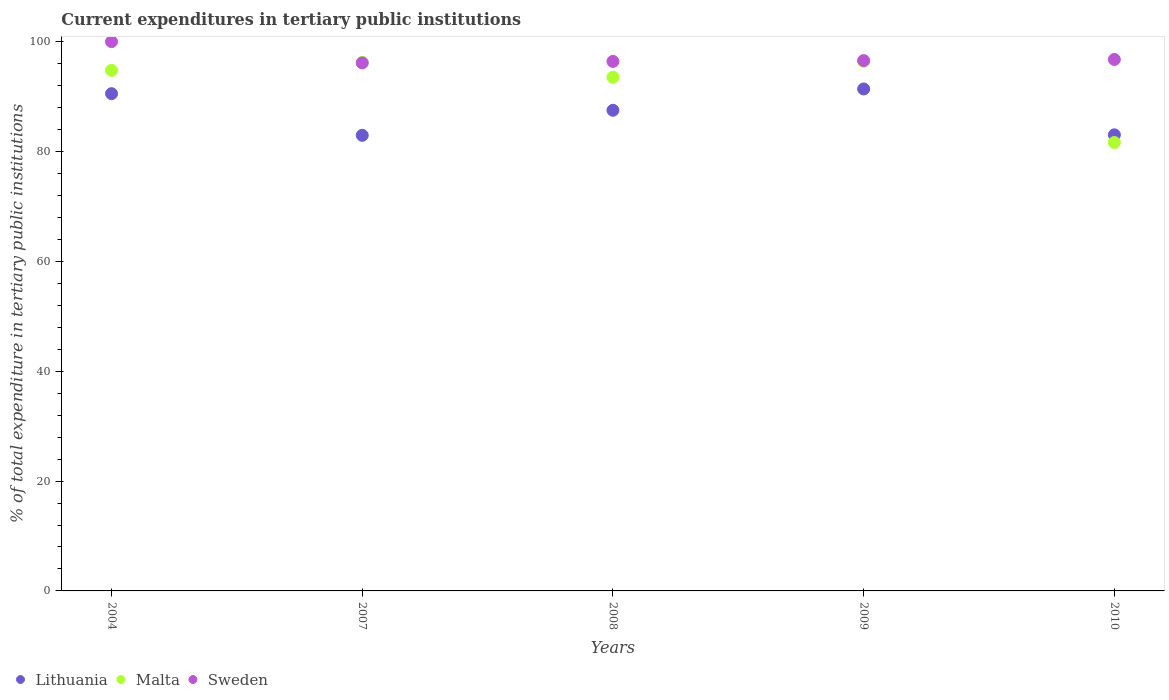How many different coloured dotlines are there?
Your answer should be very brief. 3. What is the current expenditures in tertiary public institutions in Sweden in 2009?
Offer a terse response. 96.54. Across all years, what is the maximum current expenditures in tertiary public institutions in Lithuania?
Offer a terse response. 91.38. Across all years, what is the minimum current expenditures in tertiary public institutions in Malta?
Your answer should be compact. 81.63. What is the total current expenditures in tertiary public institutions in Malta in the graph?
Your answer should be compact. 462.58. What is the difference between the current expenditures in tertiary public institutions in Lithuania in 2007 and that in 2008?
Keep it short and to the point. -4.56. What is the difference between the current expenditures in tertiary public institutions in Sweden in 2004 and the current expenditures in tertiary public institutions in Lithuania in 2008?
Offer a very short reply. 12.5. What is the average current expenditures in tertiary public institutions in Malta per year?
Keep it short and to the point. 92.52. In the year 2004, what is the difference between the current expenditures in tertiary public institutions in Lithuania and current expenditures in tertiary public institutions in Sweden?
Your answer should be compact. -9.48. What is the ratio of the current expenditures in tertiary public institutions in Malta in 2004 to that in 2009?
Keep it short and to the point. 0.98. Is the current expenditures in tertiary public institutions in Lithuania in 2008 less than that in 2009?
Make the answer very short. Yes. What is the difference between the highest and the second highest current expenditures in tertiary public institutions in Malta?
Provide a succinct answer. 0.21. What is the difference between the highest and the lowest current expenditures in tertiary public institutions in Sweden?
Your answer should be very brief. 3.88. In how many years, is the current expenditures in tertiary public institutions in Sweden greater than the average current expenditures in tertiary public institutions in Sweden taken over all years?
Provide a short and direct response. 1. Is the sum of the current expenditures in tertiary public institutions in Malta in 2009 and 2010 greater than the maximum current expenditures in tertiary public institutions in Sweden across all years?
Offer a very short reply. Yes. Is it the case that in every year, the sum of the current expenditures in tertiary public institutions in Lithuania and current expenditures in tertiary public institutions in Sweden  is greater than the current expenditures in tertiary public institutions in Malta?
Provide a short and direct response. Yes. Are the values on the major ticks of Y-axis written in scientific E-notation?
Your answer should be compact. No. Does the graph contain grids?
Give a very brief answer. No. What is the title of the graph?
Your response must be concise. Current expenditures in tertiary public institutions. Does "Albania" appear as one of the legend labels in the graph?
Provide a short and direct response. No. What is the label or title of the Y-axis?
Your answer should be very brief. % of total expenditure in tertiary public institutions. What is the % of total expenditure in tertiary public institutions of Lithuania in 2004?
Offer a terse response. 90.52. What is the % of total expenditure in tertiary public institutions of Malta in 2004?
Keep it short and to the point. 94.77. What is the % of total expenditure in tertiary public institutions in Lithuania in 2007?
Keep it short and to the point. 82.94. What is the % of total expenditure in tertiary public institutions in Malta in 2007?
Keep it short and to the point. 96.23. What is the % of total expenditure in tertiary public institutions in Sweden in 2007?
Your answer should be very brief. 96.12. What is the % of total expenditure in tertiary public institutions of Lithuania in 2008?
Make the answer very short. 87.5. What is the % of total expenditure in tertiary public institutions of Malta in 2008?
Provide a short and direct response. 93.5. What is the % of total expenditure in tertiary public institutions of Sweden in 2008?
Give a very brief answer. 96.39. What is the % of total expenditure in tertiary public institutions in Lithuania in 2009?
Give a very brief answer. 91.38. What is the % of total expenditure in tertiary public institutions of Malta in 2009?
Keep it short and to the point. 96.44. What is the % of total expenditure in tertiary public institutions of Sweden in 2009?
Provide a short and direct response. 96.54. What is the % of total expenditure in tertiary public institutions in Lithuania in 2010?
Give a very brief answer. 83.03. What is the % of total expenditure in tertiary public institutions in Malta in 2010?
Give a very brief answer. 81.63. What is the % of total expenditure in tertiary public institutions of Sweden in 2010?
Your answer should be compact. 96.75. Across all years, what is the maximum % of total expenditure in tertiary public institutions of Lithuania?
Keep it short and to the point. 91.38. Across all years, what is the maximum % of total expenditure in tertiary public institutions in Malta?
Offer a terse response. 96.44. Across all years, what is the maximum % of total expenditure in tertiary public institutions in Sweden?
Keep it short and to the point. 100. Across all years, what is the minimum % of total expenditure in tertiary public institutions in Lithuania?
Ensure brevity in your answer.  82.94. Across all years, what is the minimum % of total expenditure in tertiary public institutions of Malta?
Your answer should be compact. 81.63. Across all years, what is the minimum % of total expenditure in tertiary public institutions in Sweden?
Your answer should be compact. 96.12. What is the total % of total expenditure in tertiary public institutions of Lithuania in the graph?
Offer a terse response. 435.38. What is the total % of total expenditure in tertiary public institutions of Malta in the graph?
Give a very brief answer. 462.58. What is the total % of total expenditure in tertiary public institutions in Sweden in the graph?
Your answer should be very brief. 485.81. What is the difference between the % of total expenditure in tertiary public institutions of Lithuania in 2004 and that in 2007?
Provide a succinct answer. 7.58. What is the difference between the % of total expenditure in tertiary public institutions of Malta in 2004 and that in 2007?
Give a very brief answer. -1.46. What is the difference between the % of total expenditure in tertiary public institutions of Sweden in 2004 and that in 2007?
Keep it short and to the point. 3.88. What is the difference between the % of total expenditure in tertiary public institutions of Lithuania in 2004 and that in 2008?
Keep it short and to the point. 3.02. What is the difference between the % of total expenditure in tertiary public institutions in Malta in 2004 and that in 2008?
Ensure brevity in your answer.  1.26. What is the difference between the % of total expenditure in tertiary public institutions of Sweden in 2004 and that in 2008?
Your response must be concise. 3.6. What is the difference between the % of total expenditure in tertiary public institutions of Lithuania in 2004 and that in 2009?
Your response must be concise. -0.86. What is the difference between the % of total expenditure in tertiary public institutions of Malta in 2004 and that in 2009?
Offer a terse response. -1.67. What is the difference between the % of total expenditure in tertiary public institutions of Sweden in 2004 and that in 2009?
Offer a very short reply. 3.46. What is the difference between the % of total expenditure in tertiary public institutions in Lithuania in 2004 and that in 2010?
Give a very brief answer. 7.49. What is the difference between the % of total expenditure in tertiary public institutions in Malta in 2004 and that in 2010?
Keep it short and to the point. 13.13. What is the difference between the % of total expenditure in tertiary public institutions in Sweden in 2004 and that in 2010?
Offer a terse response. 3.25. What is the difference between the % of total expenditure in tertiary public institutions of Lithuania in 2007 and that in 2008?
Give a very brief answer. -4.56. What is the difference between the % of total expenditure in tertiary public institutions of Malta in 2007 and that in 2008?
Make the answer very short. 2.73. What is the difference between the % of total expenditure in tertiary public institutions in Sweden in 2007 and that in 2008?
Provide a succinct answer. -0.28. What is the difference between the % of total expenditure in tertiary public institutions of Lithuania in 2007 and that in 2009?
Provide a short and direct response. -8.44. What is the difference between the % of total expenditure in tertiary public institutions in Malta in 2007 and that in 2009?
Keep it short and to the point. -0.21. What is the difference between the % of total expenditure in tertiary public institutions in Sweden in 2007 and that in 2009?
Keep it short and to the point. -0.43. What is the difference between the % of total expenditure in tertiary public institutions in Lithuania in 2007 and that in 2010?
Make the answer very short. -0.09. What is the difference between the % of total expenditure in tertiary public institutions of Malta in 2007 and that in 2010?
Your response must be concise. 14.6. What is the difference between the % of total expenditure in tertiary public institutions in Sweden in 2007 and that in 2010?
Provide a succinct answer. -0.63. What is the difference between the % of total expenditure in tertiary public institutions in Lithuania in 2008 and that in 2009?
Provide a short and direct response. -3.88. What is the difference between the % of total expenditure in tertiary public institutions of Malta in 2008 and that in 2009?
Offer a very short reply. -2.94. What is the difference between the % of total expenditure in tertiary public institutions in Sweden in 2008 and that in 2009?
Provide a short and direct response. -0.15. What is the difference between the % of total expenditure in tertiary public institutions in Lithuania in 2008 and that in 2010?
Your answer should be compact. 4.47. What is the difference between the % of total expenditure in tertiary public institutions in Malta in 2008 and that in 2010?
Provide a succinct answer. 11.87. What is the difference between the % of total expenditure in tertiary public institutions in Sweden in 2008 and that in 2010?
Give a very brief answer. -0.36. What is the difference between the % of total expenditure in tertiary public institutions in Lithuania in 2009 and that in 2010?
Your response must be concise. 8.35. What is the difference between the % of total expenditure in tertiary public institutions in Malta in 2009 and that in 2010?
Make the answer very short. 14.81. What is the difference between the % of total expenditure in tertiary public institutions of Sweden in 2009 and that in 2010?
Your response must be concise. -0.21. What is the difference between the % of total expenditure in tertiary public institutions in Lithuania in 2004 and the % of total expenditure in tertiary public institutions in Malta in 2007?
Provide a short and direct response. -5.71. What is the difference between the % of total expenditure in tertiary public institutions in Lithuania in 2004 and the % of total expenditure in tertiary public institutions in Sweden in 2007?
Keep it short and to the point. -5.6. What is the difference between the % of total expenditure in tertiary public institutions in Malta in 2004 and the % of total expenditure in tertiary public institutions in Sweden in 2007?
Provide a short and direct response. -1.35. What is the difference between the % of total expenditure in tertiary public institutions in Lithuania in 2004 and the % of total expenditure in tertiary public institutions in Malta in 2008?
Provide a succinct answer. -2.98. What is the difference between the % of total expenditure in tertiary public institutions of Lithuania in 2004 and the % of total expenditure in tertiary public institutions of Sweden in 2008?
Offer a terse response. -5.87. What is the difference between the % of total expenditure in tertiary public institutions in Malta in 2004 and the % of total expenditure in tertiary public institutions in Sweden in 2008?
Provide a short and direct response. -1.63. What is the difference between the % of total expenditure in tertiary public institutions of Lithuania in 2004 and the % of total expenditure in tertiary public institutions of Malta in 2009?
Make the answer very short. -5.92. What is the difference between the % of total expenditure in tertiary public institutions in Lithuania in 2004 and the % of total expenditure in tertiary public institutions in Sweden in 2009?
Provide a short and direct response. -6.02. What is the difference between the % of total expenditure in tertiary public institutions in Malta in 2004 and the % of total expenditure in tertiary public institutions in Sweden in 2009?
Your answer should be very brief. -1.78. What is the difference between the % of total expenditure in tertiary public institutions of Lithuania in 2004 and the % of total expenditure in tertiary public institutions of Malta in 2010?
Make the answer very short. 8.89. What is the difference between the % of total expenditure in tertiary public institutions in Lithuania in 2004 and the % of total expenditure in tertiary public institutions in Sweden in 2010?
Offer a very short reply. -6.23. What is the difference between the % of total expenditure in tertiary public institutions of Malta in 2004 and the % of total expenditure in tertiary public institutions of Sweden in 2010?
Ensure brevity in your answer.  -1.98. What is the difference between the % of total expenditure in tertiary public institutions in Lithuania in 2007 and the % of total expenditure in tertiary public institutions in Malta in 2008?
Your answer should be compact. -10.56. What is the difference between the % of total expenditure in tertiary public institutions in Lithuania in 2007 and the % of total expenditure in tertiary public institutions in Sweden in 2008?
Offer a terse response. -13.45. What is the difference between the % of total expenditure in tertiary public institutions in Malta in 2007 and the % of total expenditure in tertiary public institutions in Sweden in 2008?
Provide a short and direct response. -0.16. What is the difference between the % of total expenditure in tertiary public institutions of Lithuania in 2007 and the % of total expenditure in tertiary public institutions of Malta in 2009?
Your answer should be compact. -13.5. What is the difference between the % of total expenditure in tertiary public institutions of Lithuania in 2007 and the % of total expenditure in tertiary public institutions of Sweden in 2009?
Make the answer very short. -13.6. What is the difference between the % of total expenditure in tertiary public institutions of Malta in 2007 and the % of total expenditure in tertiary public institutions of Sweden in 2009?
Ensure brevity in your answer.  -0.31. What is the difference between the % of total expenditure in tertiary public institutions of Lithuania in 2007 and the % of total expenditure in tertiary public institutions of Malta in 2010?
Provide a short and direct response. 1.31. What is the difference between the % of total expenditure in tertiary public institutions of Lithuania in 2007 and the % of total expenditure in tertiary public institutions of Sweden in 2010?
Offer a very short reply. -13.81. What is the difference between the % of total expenditure in tertiary public institutions of Malta in 2007 and the % of total expenditure in tertiary public institutions of Sweden in 2010?
Provide a succinct answer. -0.52. What is the difference between the % of total expenditure in tertiary public institutions in Lithuania in 2008 and the % of total expenditure in tertiary public institutions in Malta in 2009?
Offer a terse response. -8.94. What is the difference between the % of total expenditure in tertiary public institutions of Lithuania in 2008 and the % of total expenditure in tertiary public institutions of Sweden in 2009?
Your response must be concise. -9.04. What is the difference between the % of total expenditure in tertiary public institutions in Malta in 2008 and the % of total expenditure in tertiary public institutions in Sweden in 2009?
Provide a succinct answer. -3.04. What is the difference between the % of total expenditure in tertiary public institutions in Lithuania in 2008 and the % of total expenditure in tertiary public institutions in Malta in 2010?
Your answer should be very brief. 5.87. What is the difference between the % of total expenditure in tertiary public institutions in Lithuania in 2008 and the % of total expenditure in tertiary public institutions in Sweden in 2010?
Offer a very short reply. -9.25. What is the difference between the % of total expenditure in tertiary public institutions in Malta in 2008 and the % of total expenditure in tertiary public institutions in Sweden in 2010?
Keep it short and to the point. -3.25. What is the difference between the % of total expenditure in tertiary public institutions of Lithuania in 2009 and the % of total expenditure in tertiary public institutions of Malta in 2010?
Offer a terse response. 9.75. What is the difference between the % of total expenditure in tertiary public institutions in Lithuania in 2009 and the % of total expenditure in tertiary public institutions in Sweden in 2010?
Keep it short and to the point. -5.37. What is the difference between the % of total expenditure in tertiary public institutions of Malta in 2009 and the % of total expenditure in tertiary public institutions of Sweden in 2010?
Make the answer very short. -0.31. What is the average % of total expenditure in tertiary public institutions in Lithuania per year?
Make the answer very short. 87.08. What is the average % of total expenditure in tertiary public institutions of Malta per year?
Make the answer very short. 92.52. What is the average % of total expenditure in tertiary public institutions of Sweden per year?
Offer a very short reply. 97.16. In the year 2004, what is the difference between the % of total expenditure in tertiary public institutions of Lithuania and % of total expenditure in tertiary public institutions of Malta?
Your answer should be very brief. -4.25. In the year 2004, what is the difference between the % of total expenditure in tertiary public institutions of Lithuania and % of total expenditure in tertiary public institutions of Sweden?
Offer a very short reply. -9.48. In the year 2004, what is the difference between the % of total expenditure in tertiary public institutions of Malta and % of total expenditure in tertiary public institutions of Sweden?
Provide a succinct answer. -5.23. In the year 2007, what is the difference between the % of total expenditure in tertiary public institutions of Lithuania and % of total expenditure in tertiary public institutions of Malta?
Provide a succinct answer. -13.29. In the year 2007, what is the difference between the % of total expenditure in tertiary public institutions in Lithuania and % of total expenditure in tertiary public institutions in Sweden?
Offer a terse response. -13.18. In the year 2007, what is the difference between the % of total expenditure in tertiary public institutions in Malta and % of total expenditure in tertiary public institutions in Sweden?
Offer a very short reply. 0.11. In the year 2008, what is the difference between the % of total expenditure in tertiary public institutions of Lithuania and % of total expenditure in tertiary public institutions of Malta?
Give a very brief answer. -6. In the year 2008, what is the difference between the % of total expenditure in tertiary public institutions of Lithuania and % of total expenditure in tertiary public institutions of Sweden?
Your answer should be very brief. -8.89. In the year 2008, what is the difference between the % of total expenditure in tertiary public institutions of Malta and % of total expenditure in tertiary public institutions of Sweden?
Offer a very short reply. -2.89. In the year 2009, what is the difference between the % of total expenditure in tertiary public institutions in Lithuania and % of total expenditure in tertiary public institutions in Malta?
Your answer should be very brief. -5.06. In the year 2009, what is the difference between the % of total expenditure in tertiary public institutions of Lithuania and % of total expenditure in tertiary public institutions of Sweden?
Keep it short and to the point. -5.16. In the year 2009, what is the difference between the % of total expenditure in tertiary public institutions of Malta and % of total expenditure in tertiary public institutions of Sweden?
Offer a very short reply. -0.1. In the year 2010, what is the difference between the % of total expenditure in tertiary public institutions in Lithuania and % of total expenditure in tertiary public institutions in Malta?
Provide a short and direct response. 1.4. In the year 2010, what is the difference between the % of total expenditure in tertiary public institutions of Lithuania and % of total expenditure in tertiary public institutions of Sweden?
Your answer should be compact. -13.72. In the year 2010, what is the difference between the % of total expenditure in tertiary public institutions of Malta and % of total expenditure in tertiary public institutions of Sweden?
Your answer should be very brief. -15.12. What is the ratio of the % of total expenditure in tertiary public institutions of Lithuania in 2004 to that in 2007?
Your answer should be compact. 1.09. What is the ratio of the % of total expenditure in tertiary public institutions of Sweden in 2004 to that in 2007?
Ensure brevity in your answer.  1.04. What is the ratio of the % of total expenditure in tertiary public institutions of Lithuania in 2004 to that in 2008?
Your answer should be very brief. 1.03. What is the ratio of the % of total expenditure in tertiary public institutions of Malta in 2004 to that in 2008?
Ensure brevity in your answer.  1.01. What is the ratio of the % of total expenditure in tertiary public institutions in Sweden in 2004 to that in 2008?
Your response must be concise. 1.04. What is the ratio of the % of total expenditure in tertiary public institutions in Lithuania in 2004 to that in 2009?
Offer a terse response. 0.99. What is the ratio of the % of total expenditure in tertiary public institutions in Malta in 2004 to that in 2009?
Your answer should be compact. 0.98. What is the ratio of the % of total expenditure in tertiary public institutions in Sweden in 2004 to that in 2009?
Offer a terse response. 1.04. What is the ratio of the % of total expenditure in tertiary public institutions in Lithuania in 2004 to that in 2010?
Your response must be concise. 1.09. What is the ratio of the % of total expenditure in tertiary public institutions in Malta in 2004 to that in 2010?
Offer a very short reply. 1.16. What is the ratio of the % of total expenditure in tertiary public institutions of Sweden in 2004 to that in 2010?
Your answer should be compact. 1.03. What is the ratio of the % of total expenditure in tertiary public institutions of Lithuania in 2007 to that in 2008?
Provide a succinct answer. 0.95. What is the ratio of the % of total expenditure in tertiary public institutions of Malta in 2007 to that in 2008?
Your answer should be compact. 1.03. What is the ratio of the % of total expenditure in tertiary public institutions in Sweden in 2007 to that in 2008?
Offer a terse response. 1. What is the ratio of the % of total expenditure in tertiary public institutions of Lithuania in 2007 to that in 2009?
Give a very brief answer. 0.91. What is the ratio of the % of total expenditure in tertiary public institutions of Malta in 2007 to that in 2009?
Your answer should be compact. 1. What is the ratio of the % of total expenditure in tertiary public institutions in Malta in 2007 to that in 2010?
Ensure brevity in your answer.  1.18. What is the ratio of the % of total expenditure in tertiary public institutions in Sweden in 2007 to that in 2010?
Keep it short and to the point. 0.99. What is the ratio of the % of total expenditure in tertiary public institutions of Lithuania in 2008 to that in 2009?
Keep it short and to the point. 0.96. What is the ratio of the % of total expenditure in tertiary public institutions in Malta in 2008 to that in 2009?
Your answer should be very brief. 0.97. What is the ratio of the % of total expenditure in tertiary public institutions of Lithuania in 2008 to that in 2010?
Keep it short and to the point. 1.05. What is the ratio of the % of total expenditure in tertiary public institutions of Malta in 2008 to that in 2010?
Make the answer very short. 1.15. What is the ratio of the % of total expenditure in tertiary public institutions in Sweden in 2008 to that in 2010?
Provide a short and direct response. 1. What is the ratio of the % of total expenditure in tertiary public institutions of Lithuania in 2009 to that in 2010?
Your response must be concise. 1.1. What is the ratio of the % of total expenditure in tertiary public institutions in Malta in 2009 to that in 2010?
Your answer should be very brief. 1.18. What is the ratio of the % of total expenditure in tertiary public institutions in Sweden in 2009 to that in 2010?
Provide a succinct answer. 1. What is the difference between the highest and the second highest % of total expenditure in tertiary public institutions of Lithuania?
Your answer should be compact. 0.86. What is the difference between the highest and the second highest % of total expenditure in tertiary public institutions in Malta?
Give a very brief answer. 0.21. What is the difference between the highest and the second highest % of total expenditure in tertiary public institutions in Sweden?
Make the answer very short. 3.25. What is the difference between the highest and the lowest % of total expenditure in tertiary public institutions in Lithuania?
Your answer should be very brief. 8.44. What is the difference between the highest and the lowest % of total expenditure in tertiary public institutions of Malta?
Your answer should be compact. 14.81. What is the difference between the highest and the lowest % of total expenditure in tertiary public institutions of Sweden?
Make the answer very short. 3.88. 